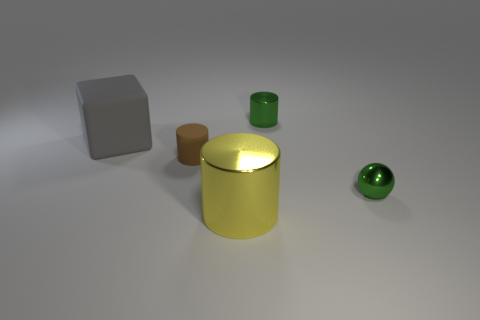How many other objects are the same shape as the brown rubber thing?
Give a very brief answer. 2. What shape is the thing that is to the left of the green shiny cylinder and in front of the brown cylinder?
Ensure brevity in your answer.  Cylinder. There is a shiny cylinder in front of the brown object; what is its size?
Provide a succinct answer. Large. Do the ball and the brown matte cylinder have the same size?
Your response must be concise. Yes. Are there fewer yellow objects behind the brown thing than large yellow things in front of the big yellow metallic object?
Your answer should be very brief. No. What is the size of the object that is to the left of the big yellow shiny thing and on the right side of the big gray thing?
Your response must be concise. Small. There is a green metallic object that is behind the small green thing that is in front of the gray matte thing; is there a big matte cube that is behind it?
Give a very brief answer. No. Are there any tiny yellow rubber cylinders?
Provide a succinct answer. No. Is the number of big gray objects that are in front of the green shiny sphere greater than the number of gray things behind the large yellow cylinder?
Make the answer very short. No. There is a ball that is the same material as the yellow thing; what size is it?
Provide a succinct answer. Small. 